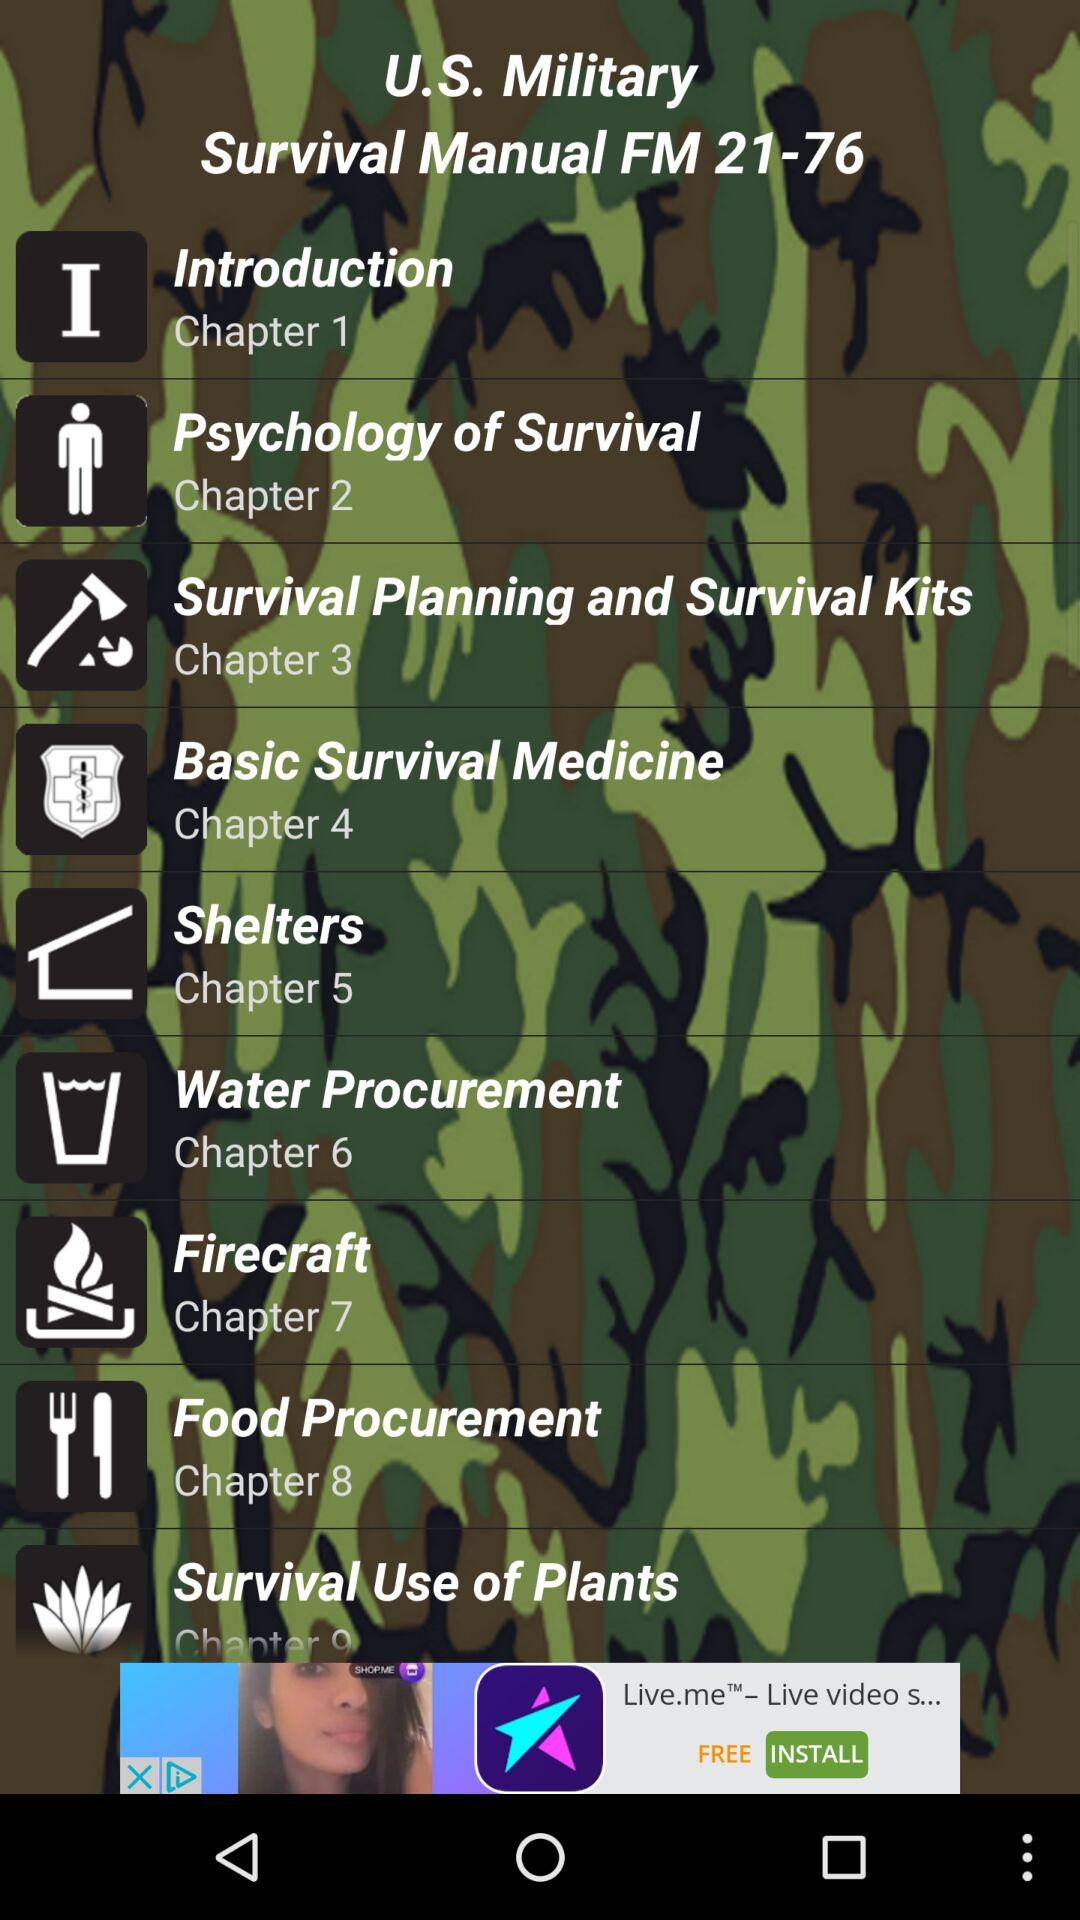What is the title of Chapter 1? The title of Chapter 1 is "Introduction". 